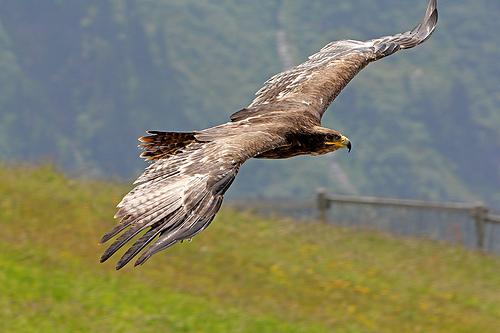How many different sections featuring fencing are mentioned in the image information? There are six sections featuring fencing mentioned in the image information. Rate the quality of the image, ensuring to address any visual issues. The quality of the image is excellent, providing clear details of the bird, fencing, and landscape. All objects are well-annotated, and there are no significant visual issues. Count the number of main subjects in the image and provide context for each. Three main subjects: 1. Large brown and white bird, possibly an eagle or hawk, flying. 2. Wooden fence along a grassy field. 3. Tree-covered mountains in the background. How would you describe the bird in the image and its action? A large brown and white bird, possibly an eagle or hawk, is flying through the air with its wings fully extended, showcasing its brown-black tail feathers and varied texture of wing feathers. What is the sentiment conveyed by the image? The image conveys a sense freedom and majesty, with the large bird soaring effortlessly above the landscape, showcasing its beauty and power. Describe the landscape below the bird and how it contributes to the overall composition of the image. The landscape below the bird consists of a green grassy field with small yellow flowers dotting the grass, wooden fencing running through it, and tree-covered mountains in the back. This landscape contributes to the overall composition by showcasing the bird's natural habitat and accentuating its magnificent presence as it soars above. Can you provide a list of objects in the image and their position, without any description of how they're interacting with each other? Bird wing feather (98, 215), bird beak (341, 137), bird eye (323, 132), large bird (70, 14), bird head (310, 122), tail feathers (130, 126), bird body (216, 117), wooden fencing (293, 184), bird flying over field (82, 11), fencing by field (245, 182). Provide a complex reasoning of what are the bird's actions tell us in relationship to the mountains in the image. The bird's actions of flying through the air suggest that it is navigating the mountainous landscape, possibly searching for prey, nesting locations, or exploring its territory. Briefly analyze the interaction between the bird and its environment. The bird is flying through the air above a grassy field, with small yellow flowers dotting the grass, and appears to be soaring above the wooden fencing and mountains in the background. What type of bird does this image depict, and what specific qualities can you highlight? The image likely depicts an eagle or a hawk, judging by its large size, hooked yellow and black beak, sharp eye, extended wings, and mix of brown, black, and white feathers. Is there a tree depicted in the image? No, it's not mentioned in the image. Evaluate the quality of the image from a scale of 1 to 10. 9 Is the bird interacting with any other living beings in the image? No How many wooden fence elements are present in the image? 7 State the sentiment associated with the small yellow flowers dotting the grass. joyful Describe the fencing along the hillside in the image. Light brown wooden fencing X:293 Y:184 Width:200 Height:200 Which object(s) depict the bird's tail feathers? section of dark brown tail feathers X:130 Y:126 Width:65 Height:65; tail feathers of a bird X:137 Y:124 Width:61 Height:61; brown and black tail feathers X:132 Y:126 Width:65 Height:65 What features of the bird's head are visible in the image? Head, eye, nostril, and beak What is the overall sentiment of the displayed image? positive In a few words, describe the elements found in the background of this image. Grassy field, wooden fence, and mountains How many objects have been detected in the image? 39 objects List the attributes of the bird's beak. Curved, black, hooked, sharp, yellow and black Compare the sharpness of the black tip of the bird's beak to the image quality. The black tip is clear, indicating good image quality. What is the position and size of the bird's eye? X:323 Y:132 Width:12 Height:12 Identify the boundaries for the area covered by green grass in the field in the image. X:4 Y:155 Width:491 Height:491 Describe the main object in the image. One large brown and white bird flying over a grassy field with a wooden fence. Can you find the red flowers on the grass? There are small yellow flowers mentioned in the image, but no red flowers are described. Which section of the bird does the object at (X:216, Y:117, Width:85, Height:85) represent? Multicolored bird body What kind of interaction can be seen between the bird and its surroundings? The bird is flying over a grassy field and a wooden fence. Identify the object that is described as "hooked beaked of eagle." One curved black bird beak X:341 Y:137 Width:15 Height:15 